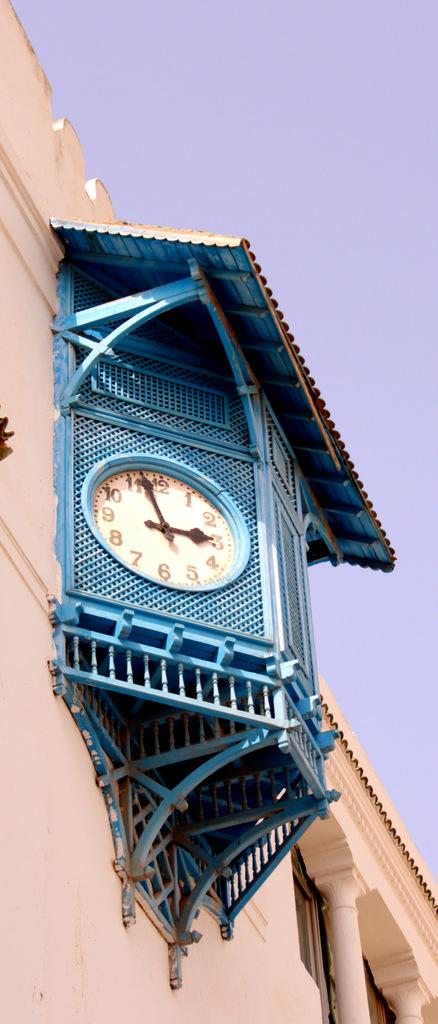<image>
Relay a brief, clear account of the picture shown. A large blue and white clock on the side of a building with the hands showing the time 2:57. 